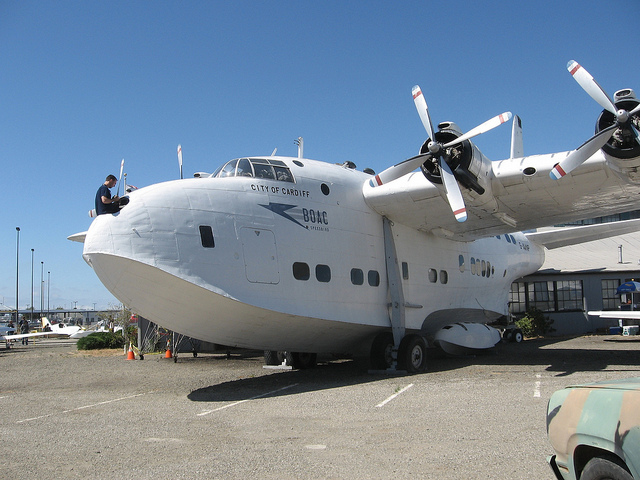Please extract the text content from this image. CITY OF CAROTEF 80AC 